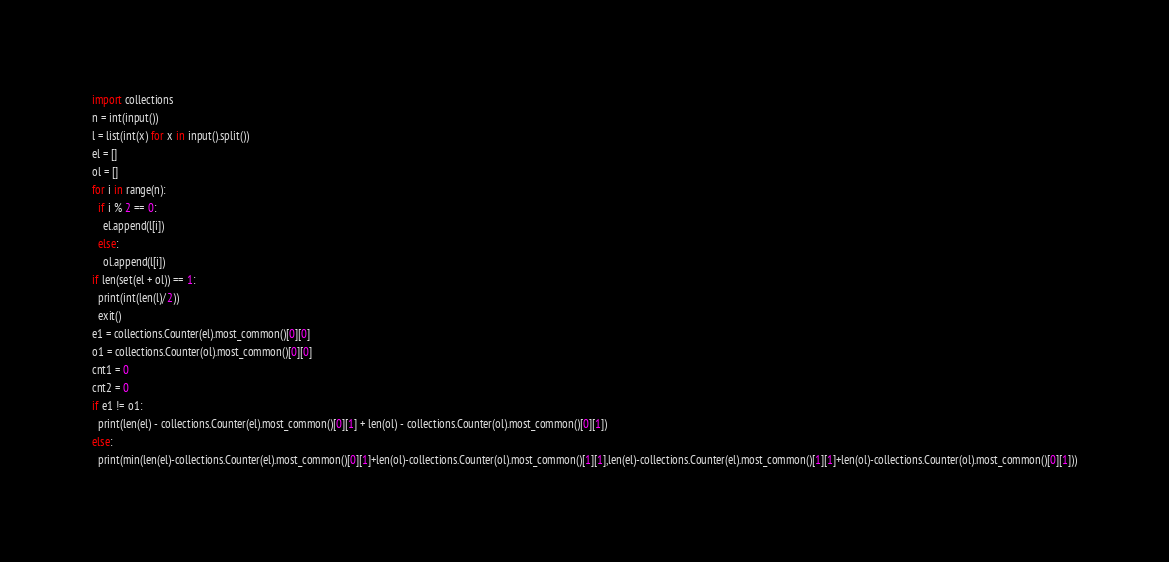<code> <loc_0><loc_0><loc_500><loc_500><_Python_>import collections
n = int(input())
l = list(int(x) for x in input().split())
el = []
ol = []
for i in range(n):
  if i % 2 == 0:
    el.append(l[i])
  else:
    ol.append(l[i])
if len(set(el + ol)) == 1:
  print(int(len(l)/2))
  exit()
e1 = collections.Counter(el).most_common()[0][0]
o1 = collections.Counter(ol).most_common()[0][0]
cnt1 = 0
cnt2 = 0
if e1 != o1:
  print(len(el) - collections.Counter(el).most_common()[0][1] + len(ol) - collections.Counter(ol).most_common()[0][1])
else:
  print(min(len(el)-collections.Counter(el).most_common()[0][1]+len(ol)-collections.Counter(ol).most_common()[1][1],len(el)-collections.Counter(el).most_common()[1][1]+len(ol)-collections.Counter(ol).most_common()[0][1]))
</code> 